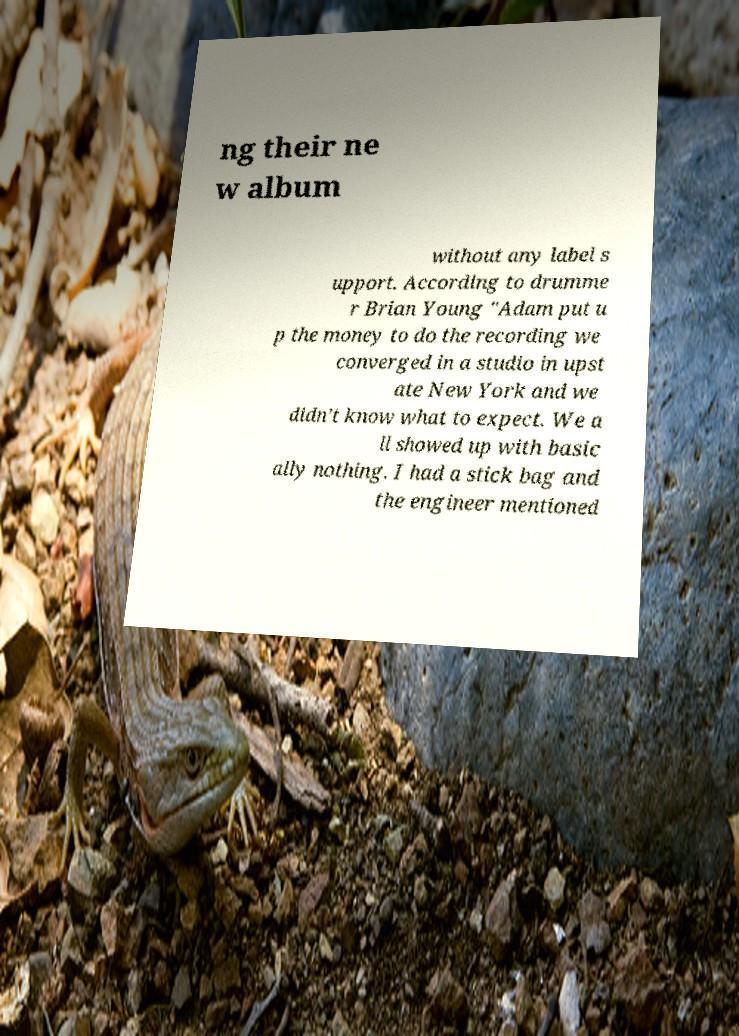Could you extract and type out the text from this image? ng their ne w album without any label s upport. According to drumme r Brian Young "Adam put u p the money to do the recording we converged in a studio in upst ate New York and we didn’t know what to expect. We a ll showed up with basic ally nothing. I had a stick bag and the engineer mentioned 